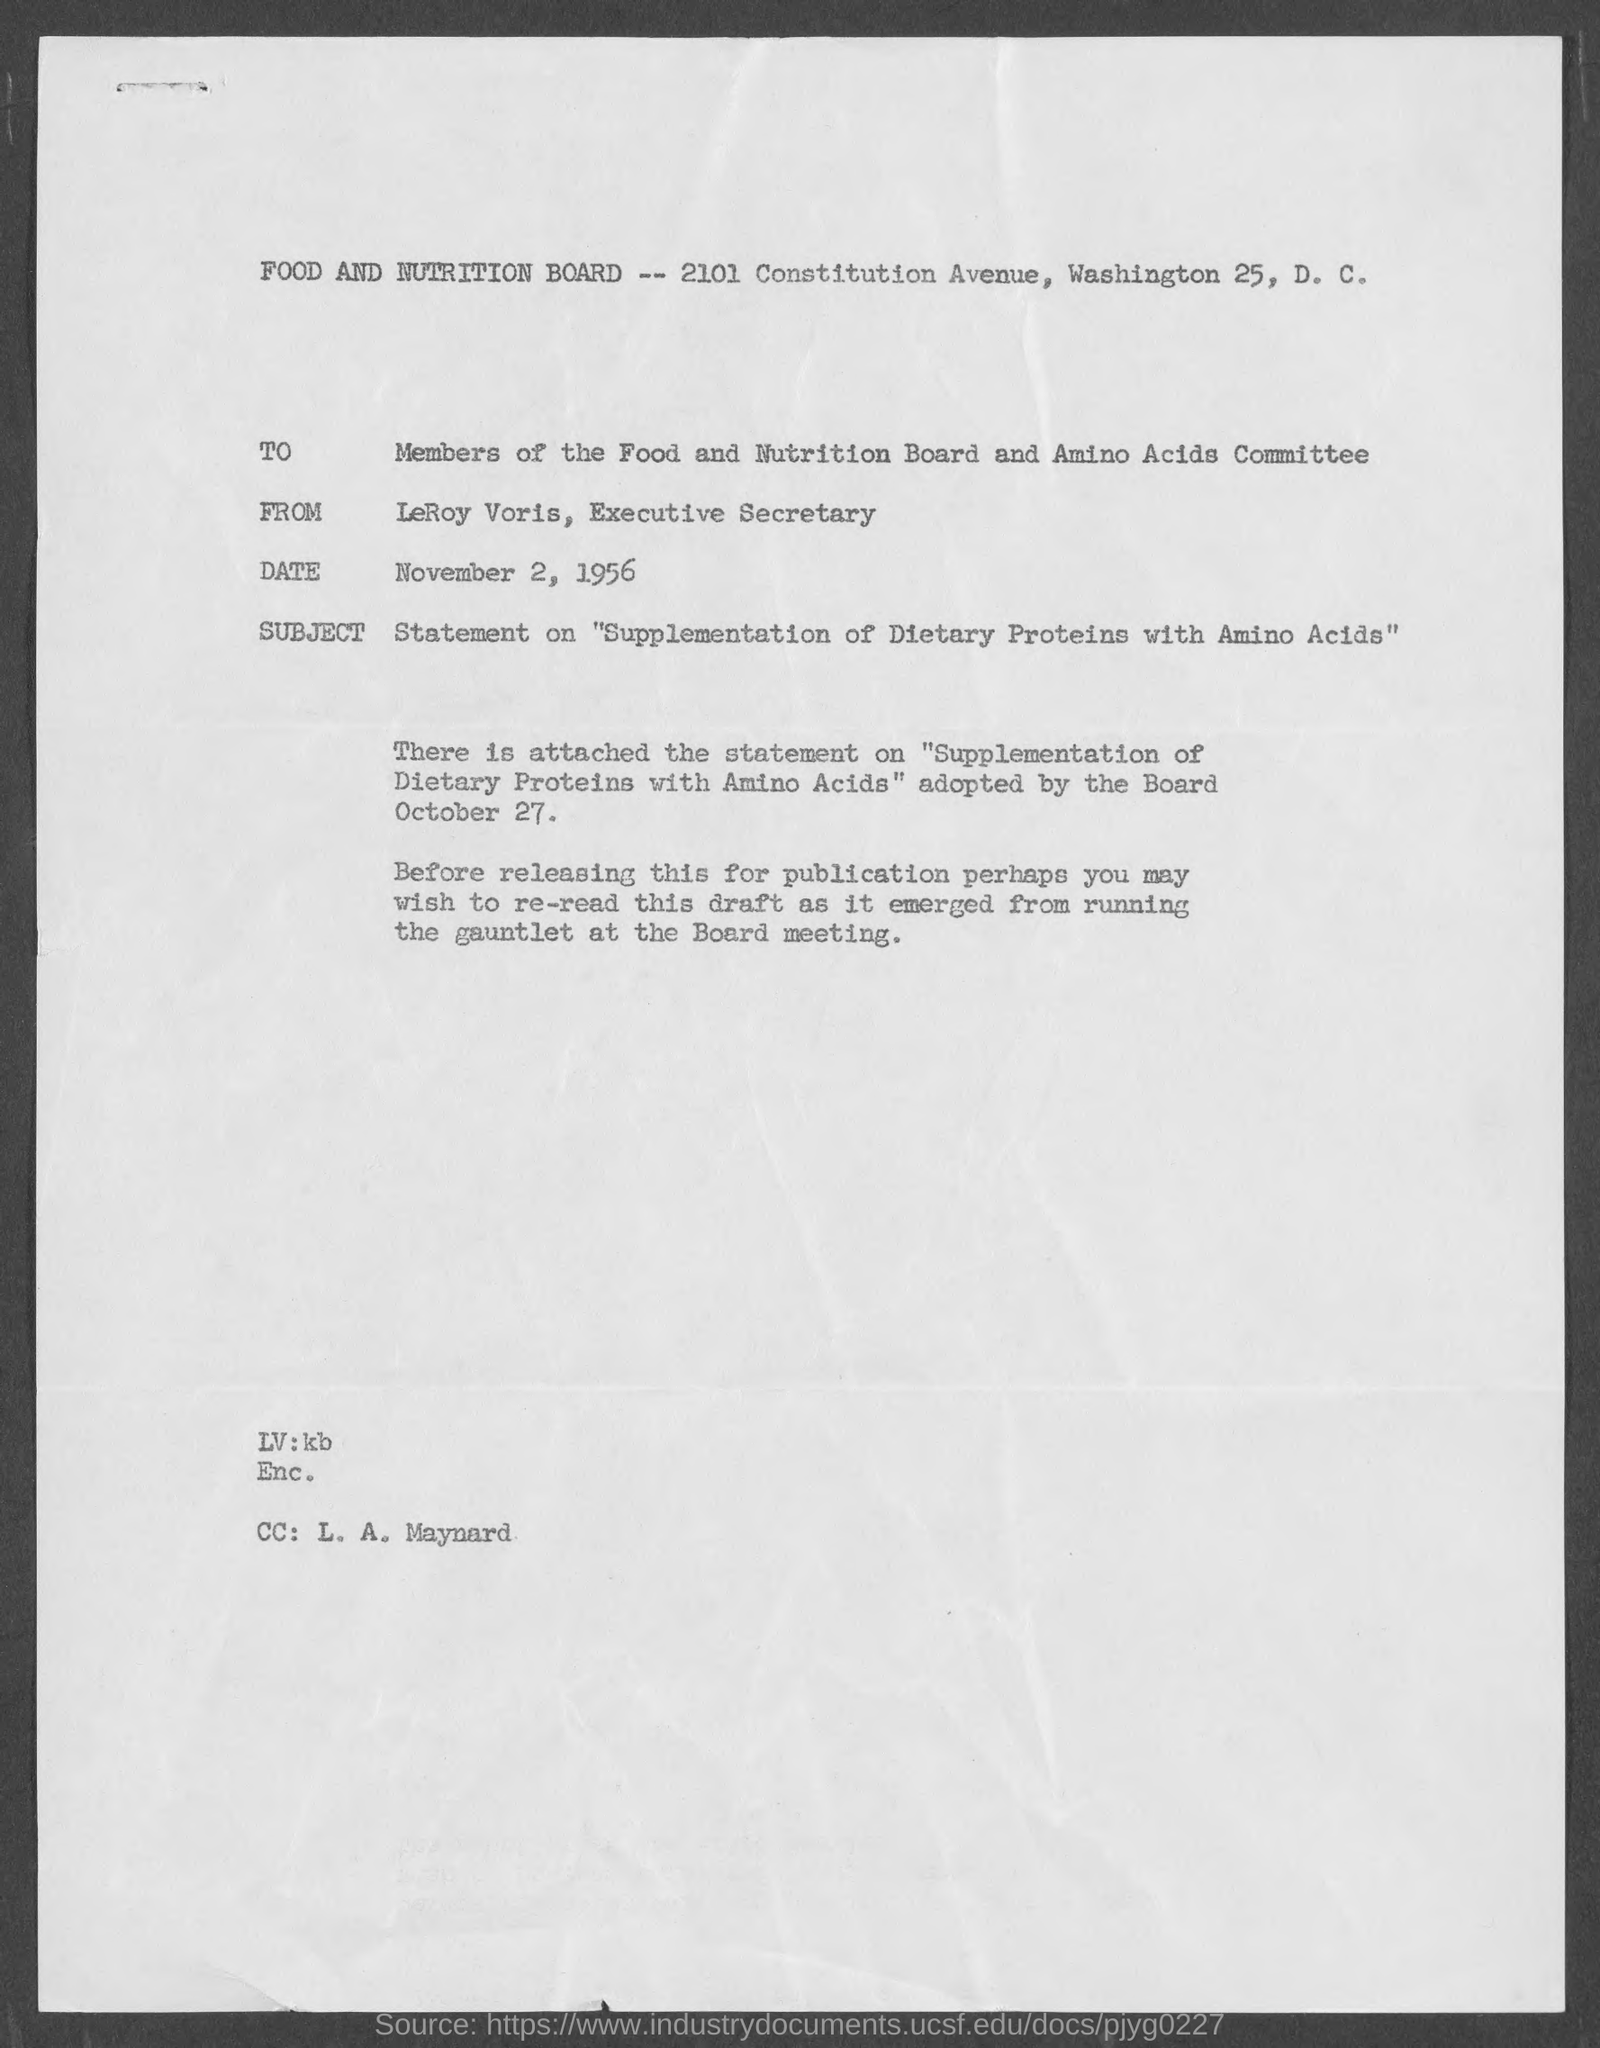What is the date?
Ensure brevity in your answer.  November 2, 1956. To whom the letter is written?
Give a very brief answer. Members of the Food and Nutrition Board and Amino Acids Committee. 